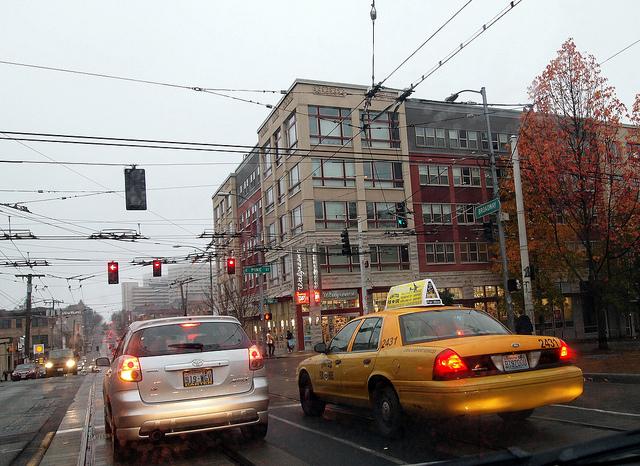What number is painted on the taxi?
Concise answer only. 2431. How many taxis are there?
Keep it brief. 1. What time of day is it?
Be succinct. Afternoon. Is the light green?
Quick response, please. No. What color is the traffic light?
Write a very short answer. Red. Is the traffic light green?
Write a very short answer. No. 